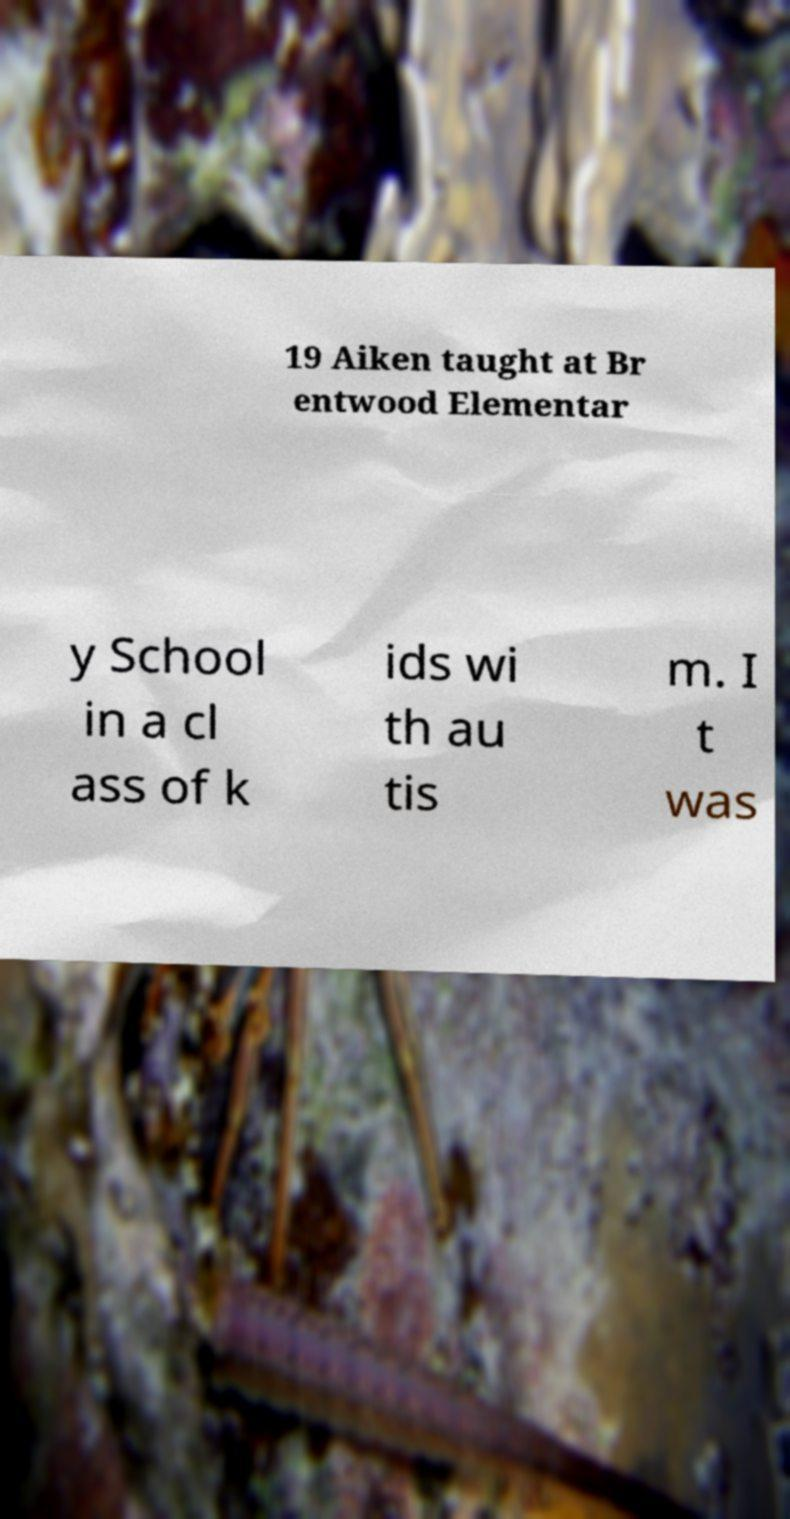Could you assist in decoding the text presented in this image and type it out clearly? 19 Aiken taught at Br entwood Elementar y School in a cl ass of k ids wi th au tis m. I t was 